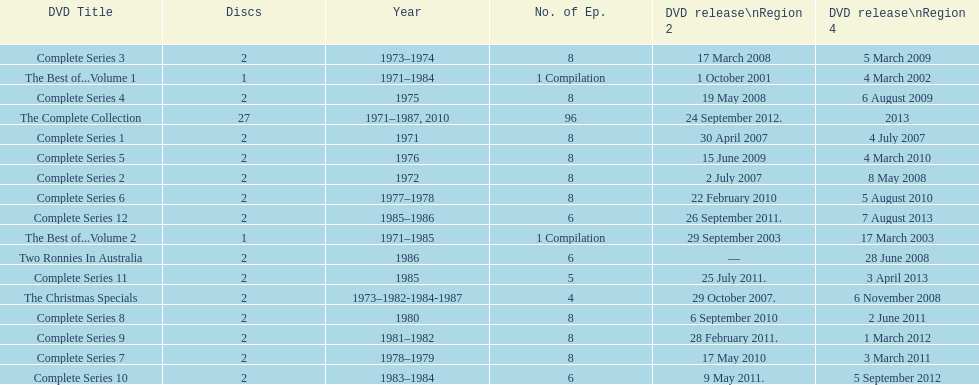Dvd shorter than 5 episodes The Christmas Specials. 